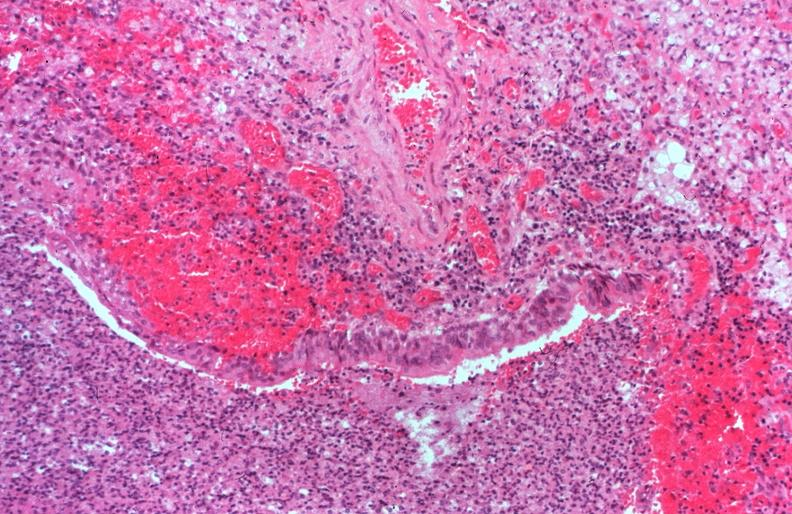s respiratory present?
Answer the question using a single word or phrase. Yes 